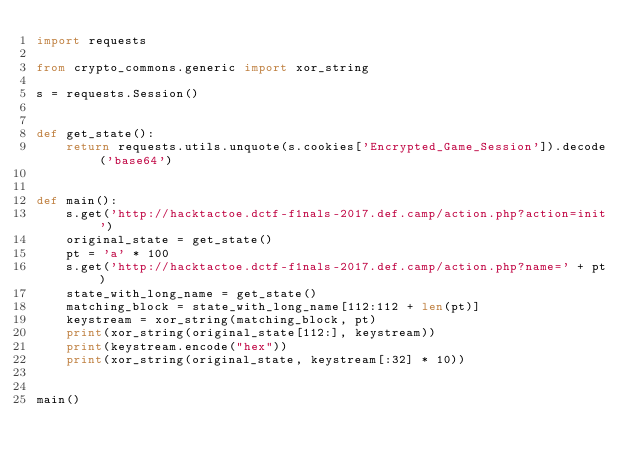Convert code to text. <code><loc_0><loc_0><loc_500><loc_500><_Python_>import requests

from crypto_commons.generic import xor_string

s = requests.Session()


def get_state():
    return requests.utils.unquote(s.cookies['Encrypted_Game_Session']).decode('base64')


def main():
    s.get('http://hacktactoe.dctf-f1nals-2017.def.camp/action.php?action=init')
    original_state = get_state()
    pt = 'a' * 100
    s.get('http://hacktactoe.dctf-f1nals-2017.def.camp/action.php?name=' + pt)
    state_with_long_name = get_state()
    matching_block = state_with_long_name[112:112 + len(pt)]
    keystream = xor_string(matching_block, pt)
    print(xor_string(original_state[112:], keystream))
    print(keystream.encode("hex"))
    print(xor_string(original_state, keystream[:32] * 10))


main()
</code> 